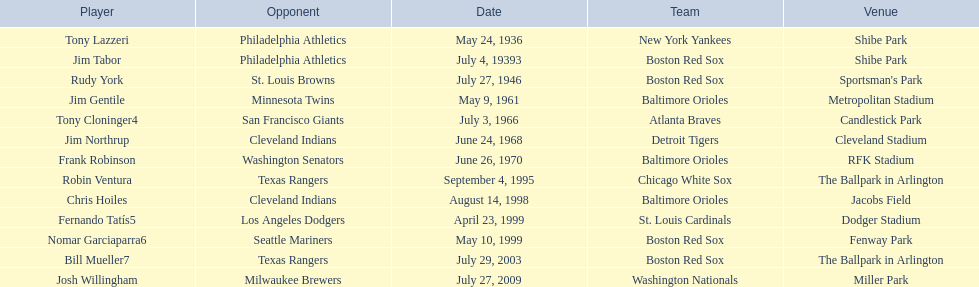What is the name of the player for the new york yankees in 1936? Tony Lazzeri. 